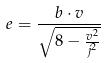<formula> <loc_0><loc_0><loc_500><loc_500>e = \frac { b \cdot v } { \sqrt { 8 - \frac { v ^ { 2 } } { j ^ { 2 } } } }</formula> 